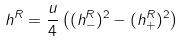Convert formula to latex. <formula><loc_0><loc_0><loc_500><loc_500>h ^ { R } = \frac { u } { 4 } \left ( ( h _ { - } ^ { R } ) ^ { 2 } - ( h _ { + } ^ { R } ) ^ { 2 } \right )</formula> 